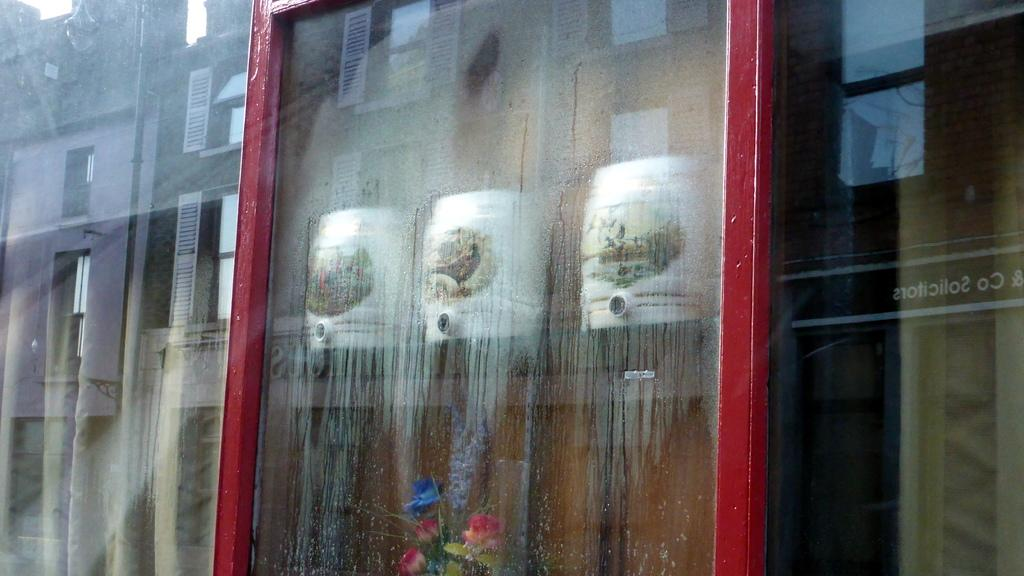What object is visible in the image that can hold a liquid? There is a glass in the image that can hold a liquid. What is located behind the glass in the image? There is a flower plant behind the glass. What type of objects are present in the image that are white and box-shaped? There are white color boxes in the image. What structure can be seen on the left side of the image? There is a building on the left side of the image. How many fingers can be seen pointing at the building in the image? There are no fingers visible in the image pointing at the building. What type of trouble is the flower plant experiencing in the image? There is no indication of any trouble for the flower plant in the image. 